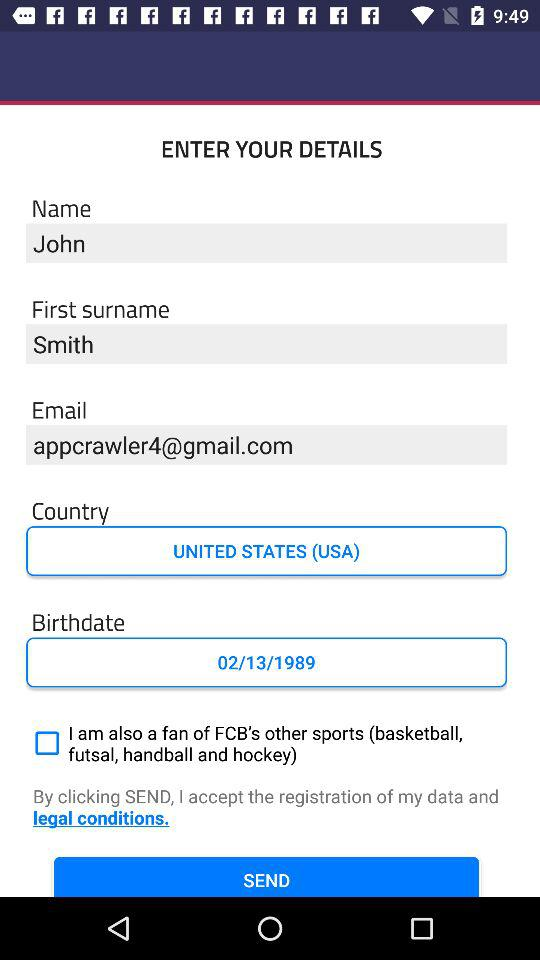What is the first surname? The first surname is Smith. 